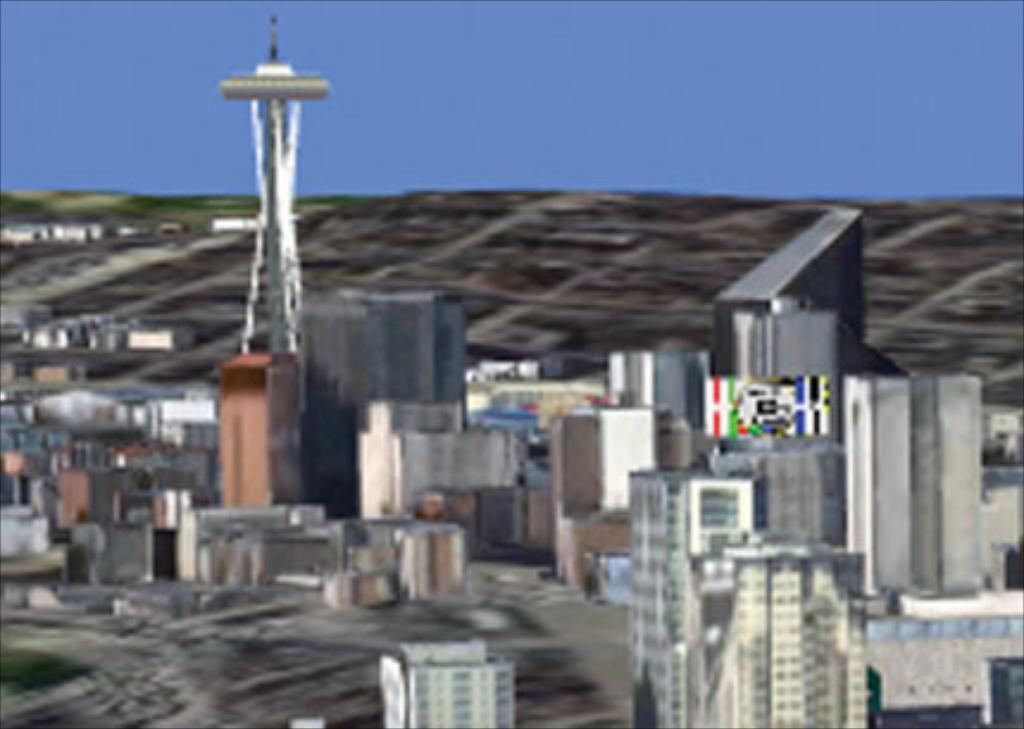In one or two sentences, can you explain what this image depicts? This is animated picture of a city were we can see tower and many buildings. The sky is in blue color. 